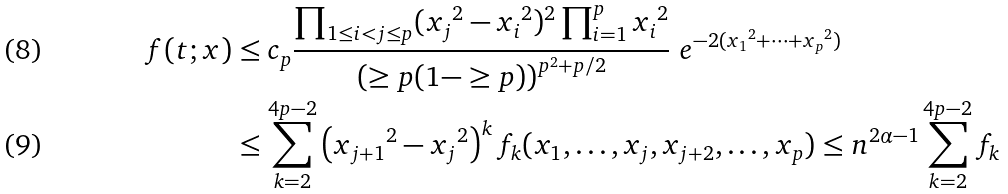<formula> <loc_0><loc_0><loc_500><loc_500>f ( t ; x ) & \leq c _ { p } \frac { \prod _ { 1 \leq i < j \leq p } ( { x _ { j } } ^ { 2 } - { x _ { i } } ^ { 2 } ) ^ { 2 } \prod _ { i = 1 } ^ { p } { x _ { i } } ^ { 2 } } { \left ( \geq p ( 1 - \geq p ) \right ) ^ { p ^ { 2 } + p / 2 } } \ e ^ { - 2 ( { x _ { 1 } } ^ { 2 } + \cdots + { x _ { p } } ^ { 2 } ) } \\ & \leq \sum _ { k = 2 } ^ { 4 p - 2 } \left ( { x _ { j + 1 } } ^ { 2 } - { x _ { j } } ^ { 2 } \right ) ^ { k } f _ { k } ( x _ { 1 } , \dots , x _ { j } , x _ { j + 2 } , \dots , x _ { p } ) \leq n ^ { 2 \alpha - 1 } \sum _ { k = 2 } ^ { 4 p - 2 } f _ { k }</formula> 